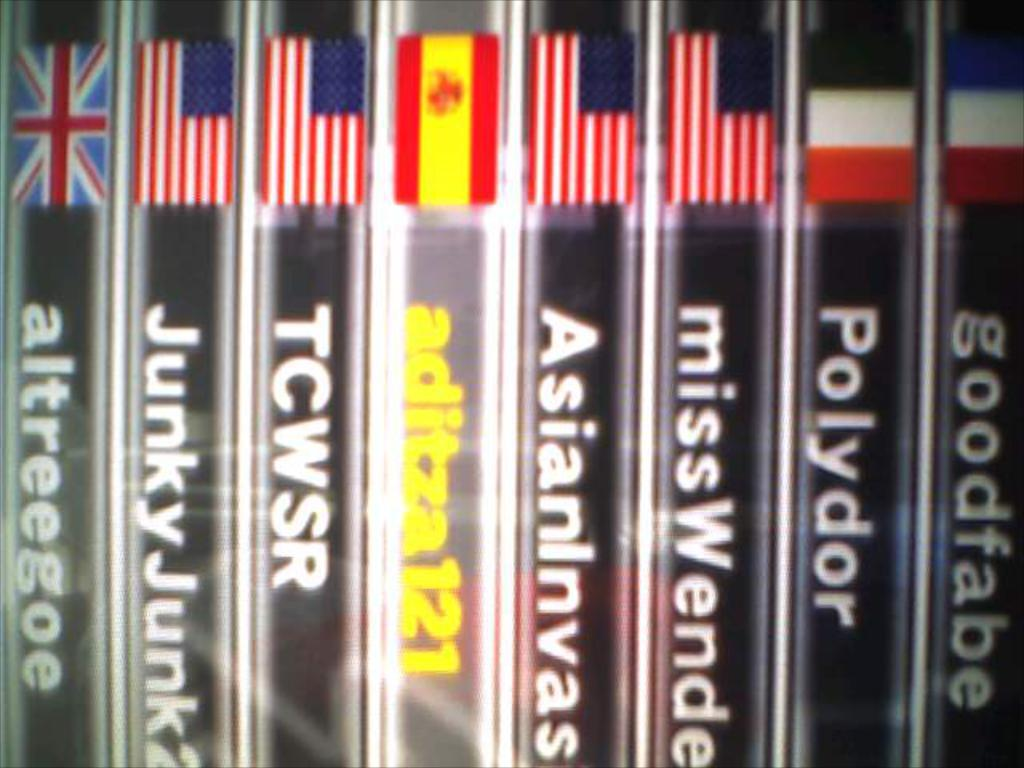<image>
Create a compact narrative representing the image presented. A set of books including Junky Junk and Goodfabe as titles 